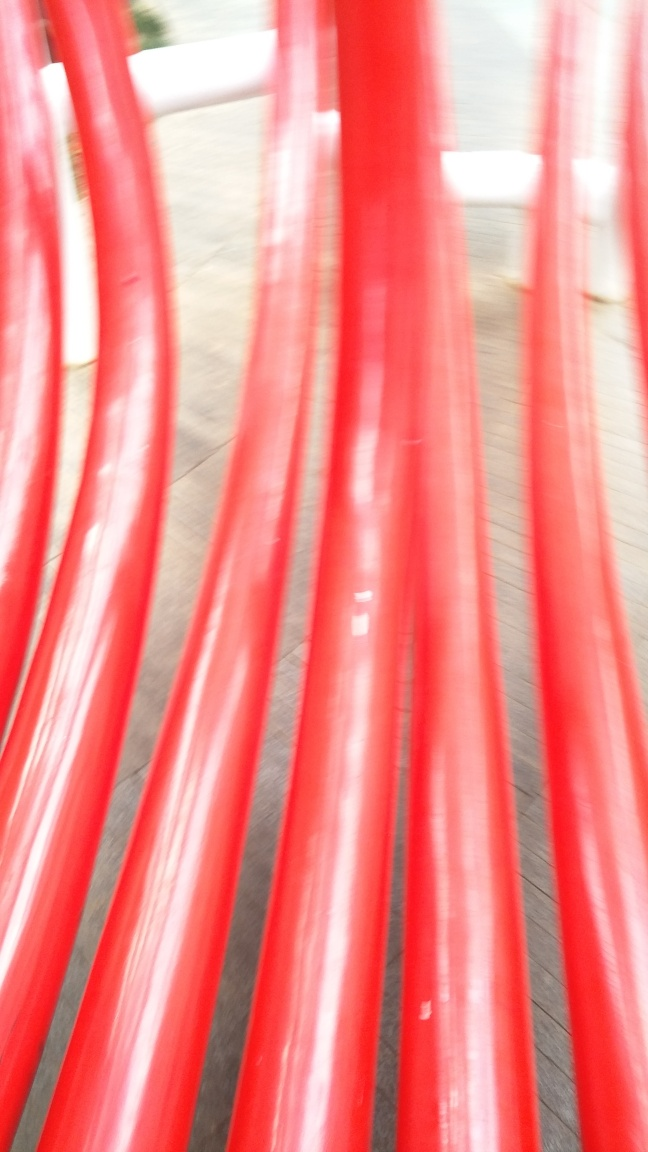Is there any indication of the location where this photo was taken? The image doesn't provide enough context to ascertain the exact location due to the lack of identifiable landmarks or signs. The blur makes it challenging to determine the setting, but the presence of hard paving on the ground hints at an urban or park environment. 